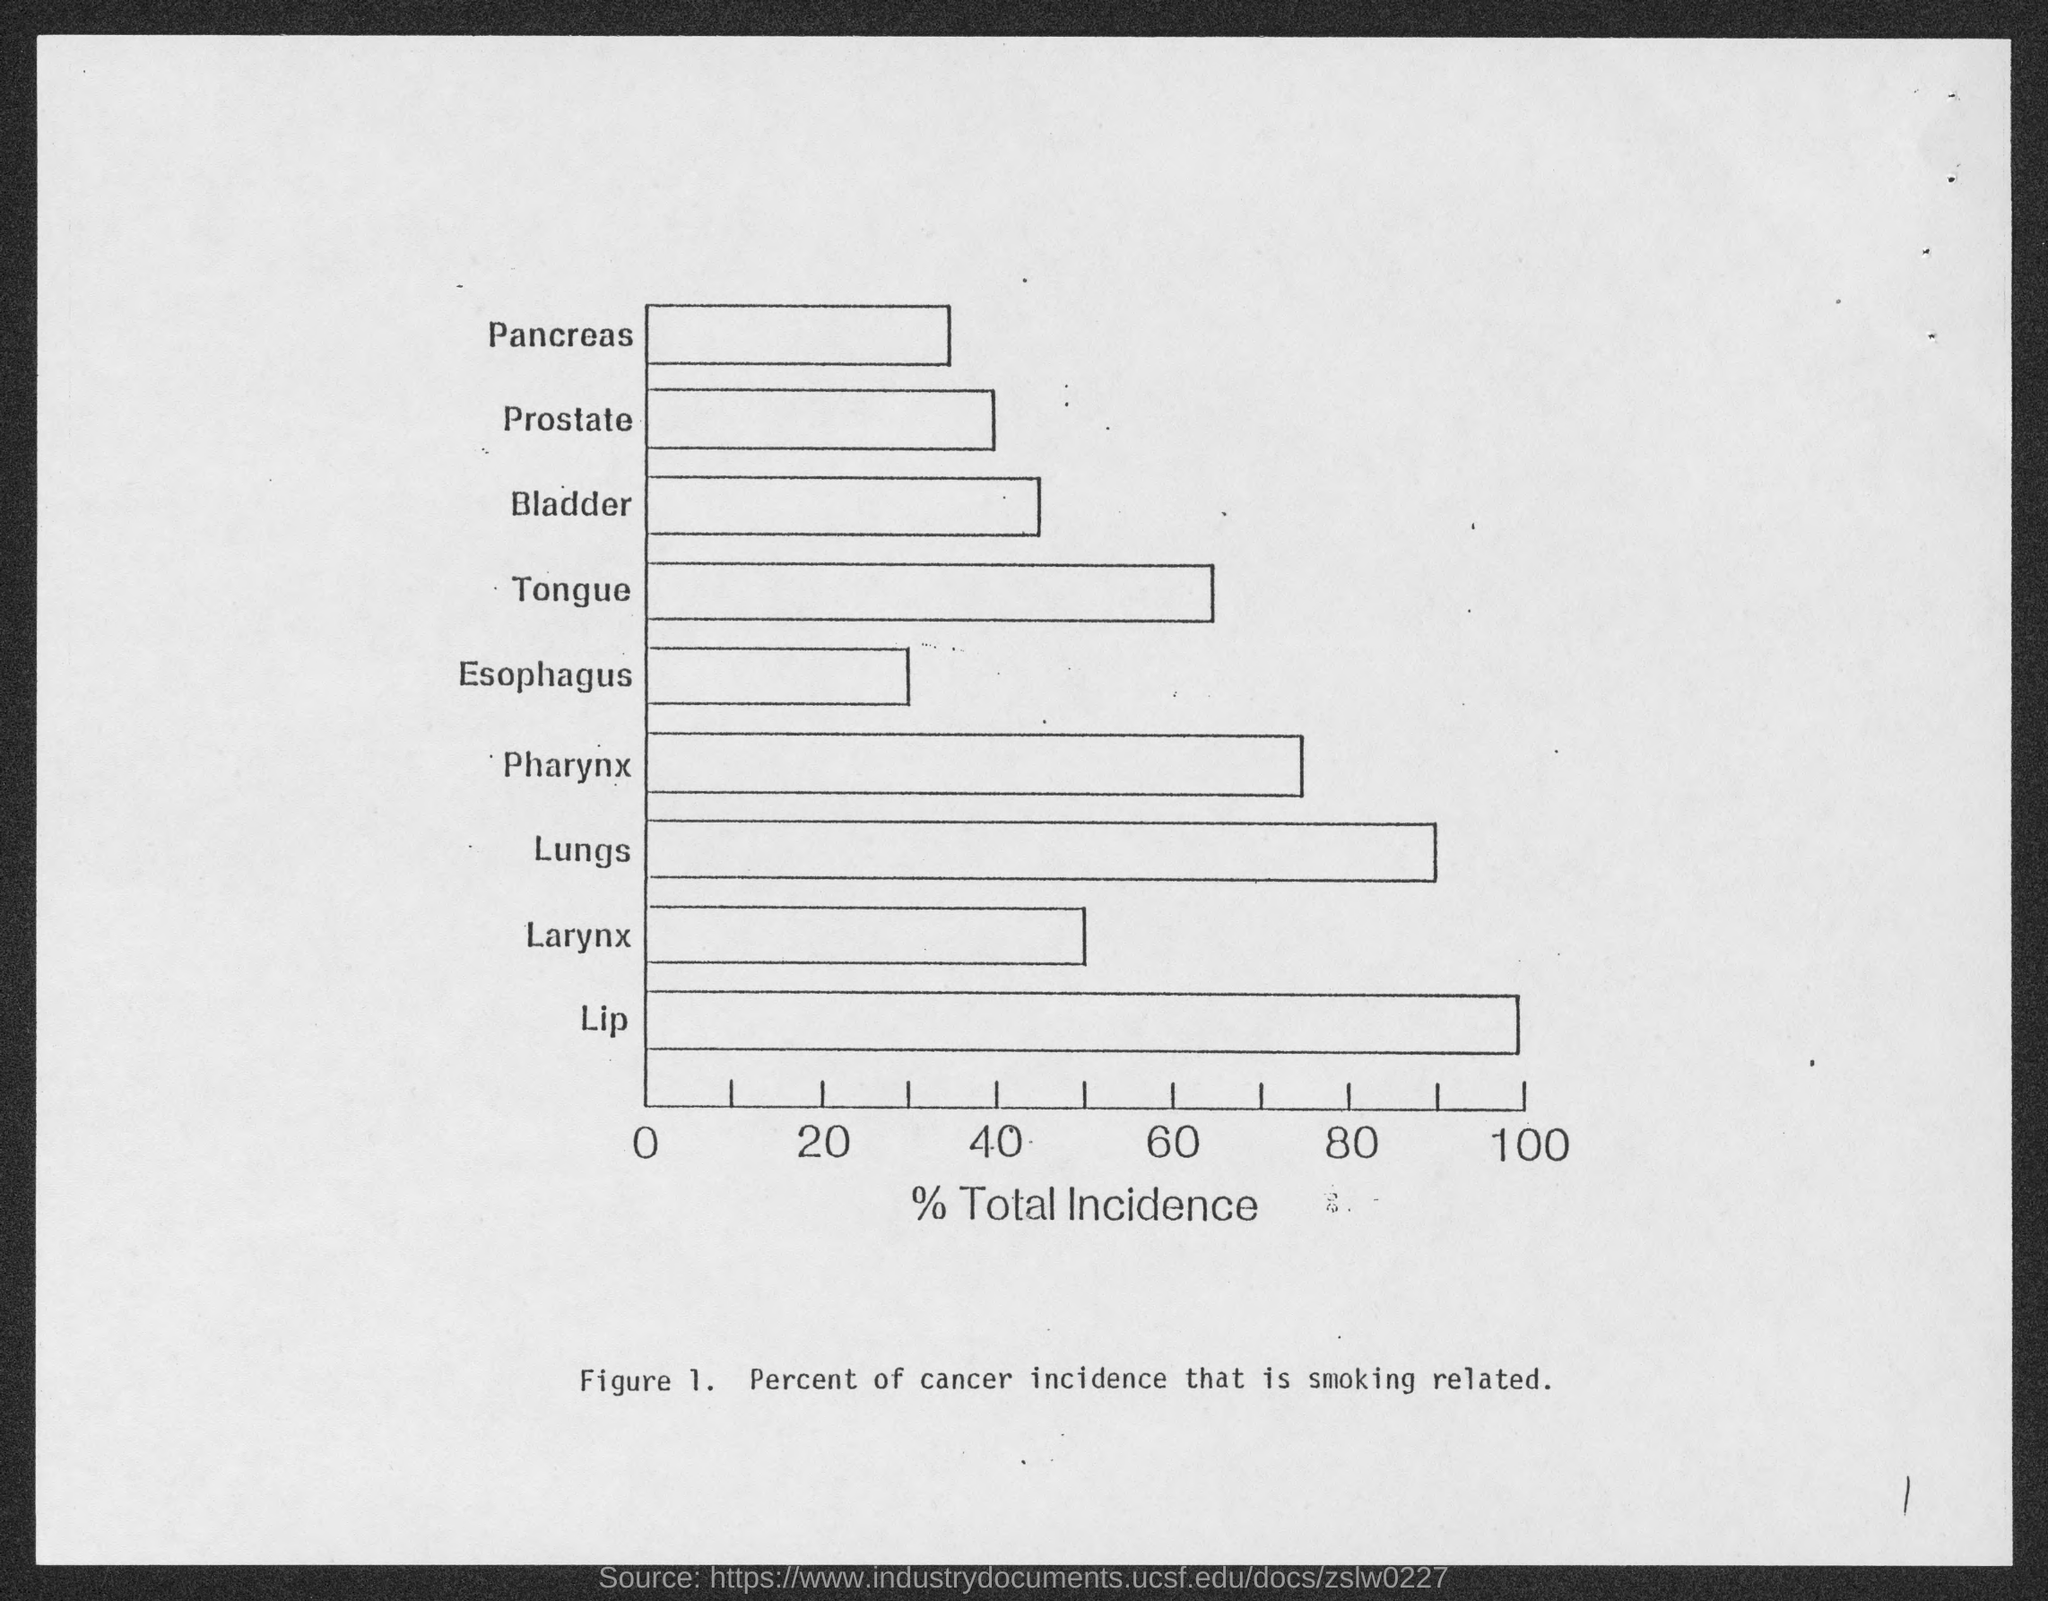Point out several critical features in this image. Figure 1 shows that smoking is responsible for a significant percentage of cancer incidence. Specifically, the figure indicates that smoking is linked to approximately X% of all cancer cases. The x-axis of Figure 1 represents the percentage of total incidence of the disease being studied. 